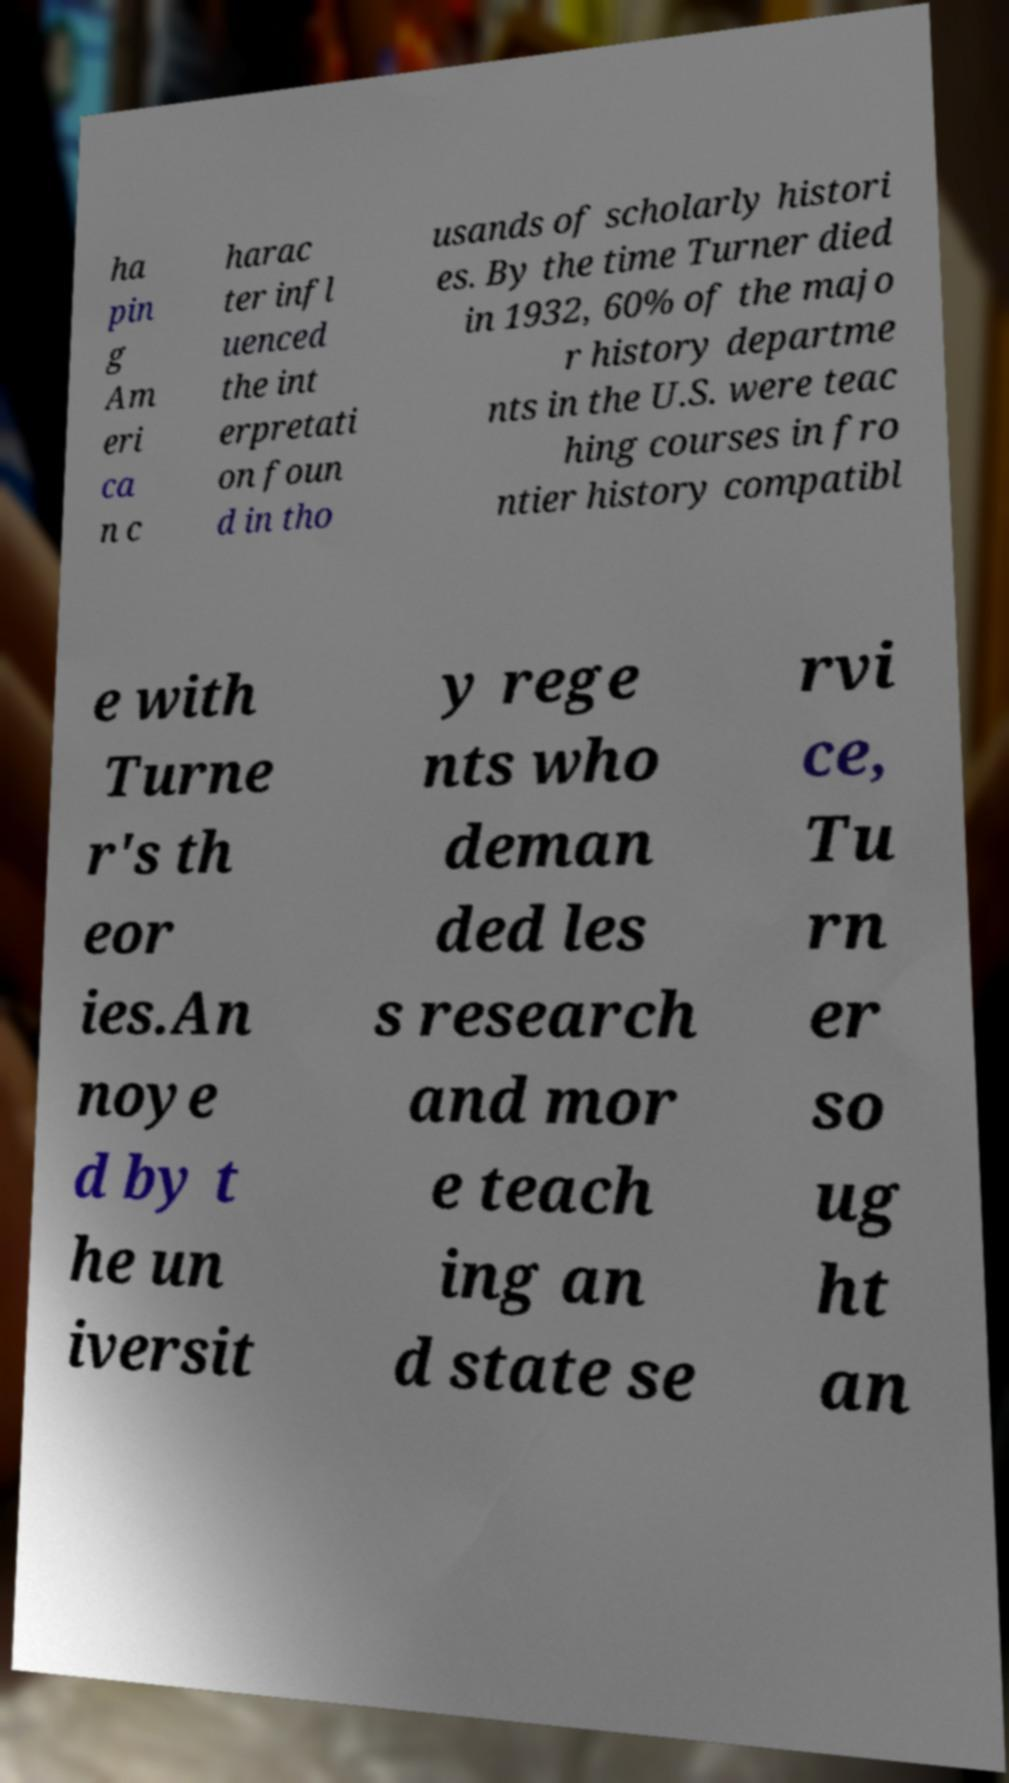Can you read and provide the text displayed in the image?This photo seems to have some interesting text. Can you extract and type it out for me? ha pin g Am eri ca n c harac ter infl uenced the int erpretati on foun d in tho usands of scholarly histori es. By the time Turner died in 1932, 60% of the majo r history departme nts in the U.S. were teac hing courses in fro ntier history compatibl e with Turne r's th eor ies.An noye d by t he un iversit y rege nts who deman ded les s research and mor e teach ing an d state se rvi ce, Tu rn er so ug ht an 